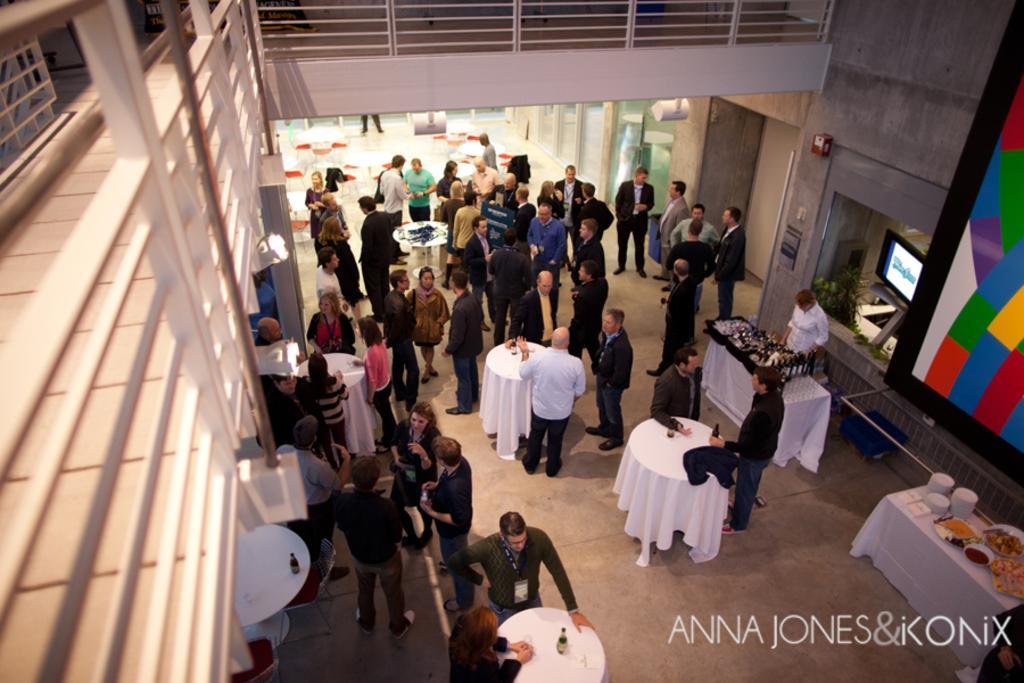Can you describe this image briefly? Here we can see some persons are standing on the floor. These are the tables. On the table there are bottles, plates, and some food. This is floor. Here we can see a screen and this is wall. And there is a door. 